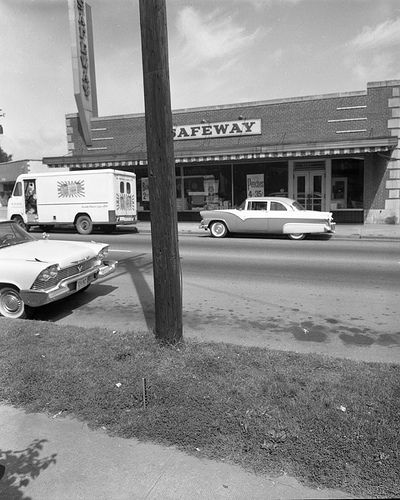<image>What year is the car? I don't know what year the car is. The possible range could be in the 1950s. What year is the car? I don't know what year is the car. 